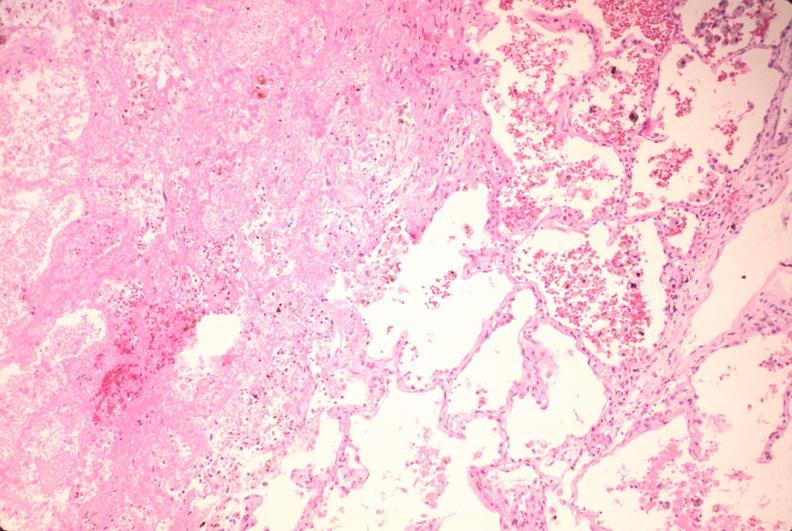what does this image show?
Answer the question using a single word or phrase. Lung 